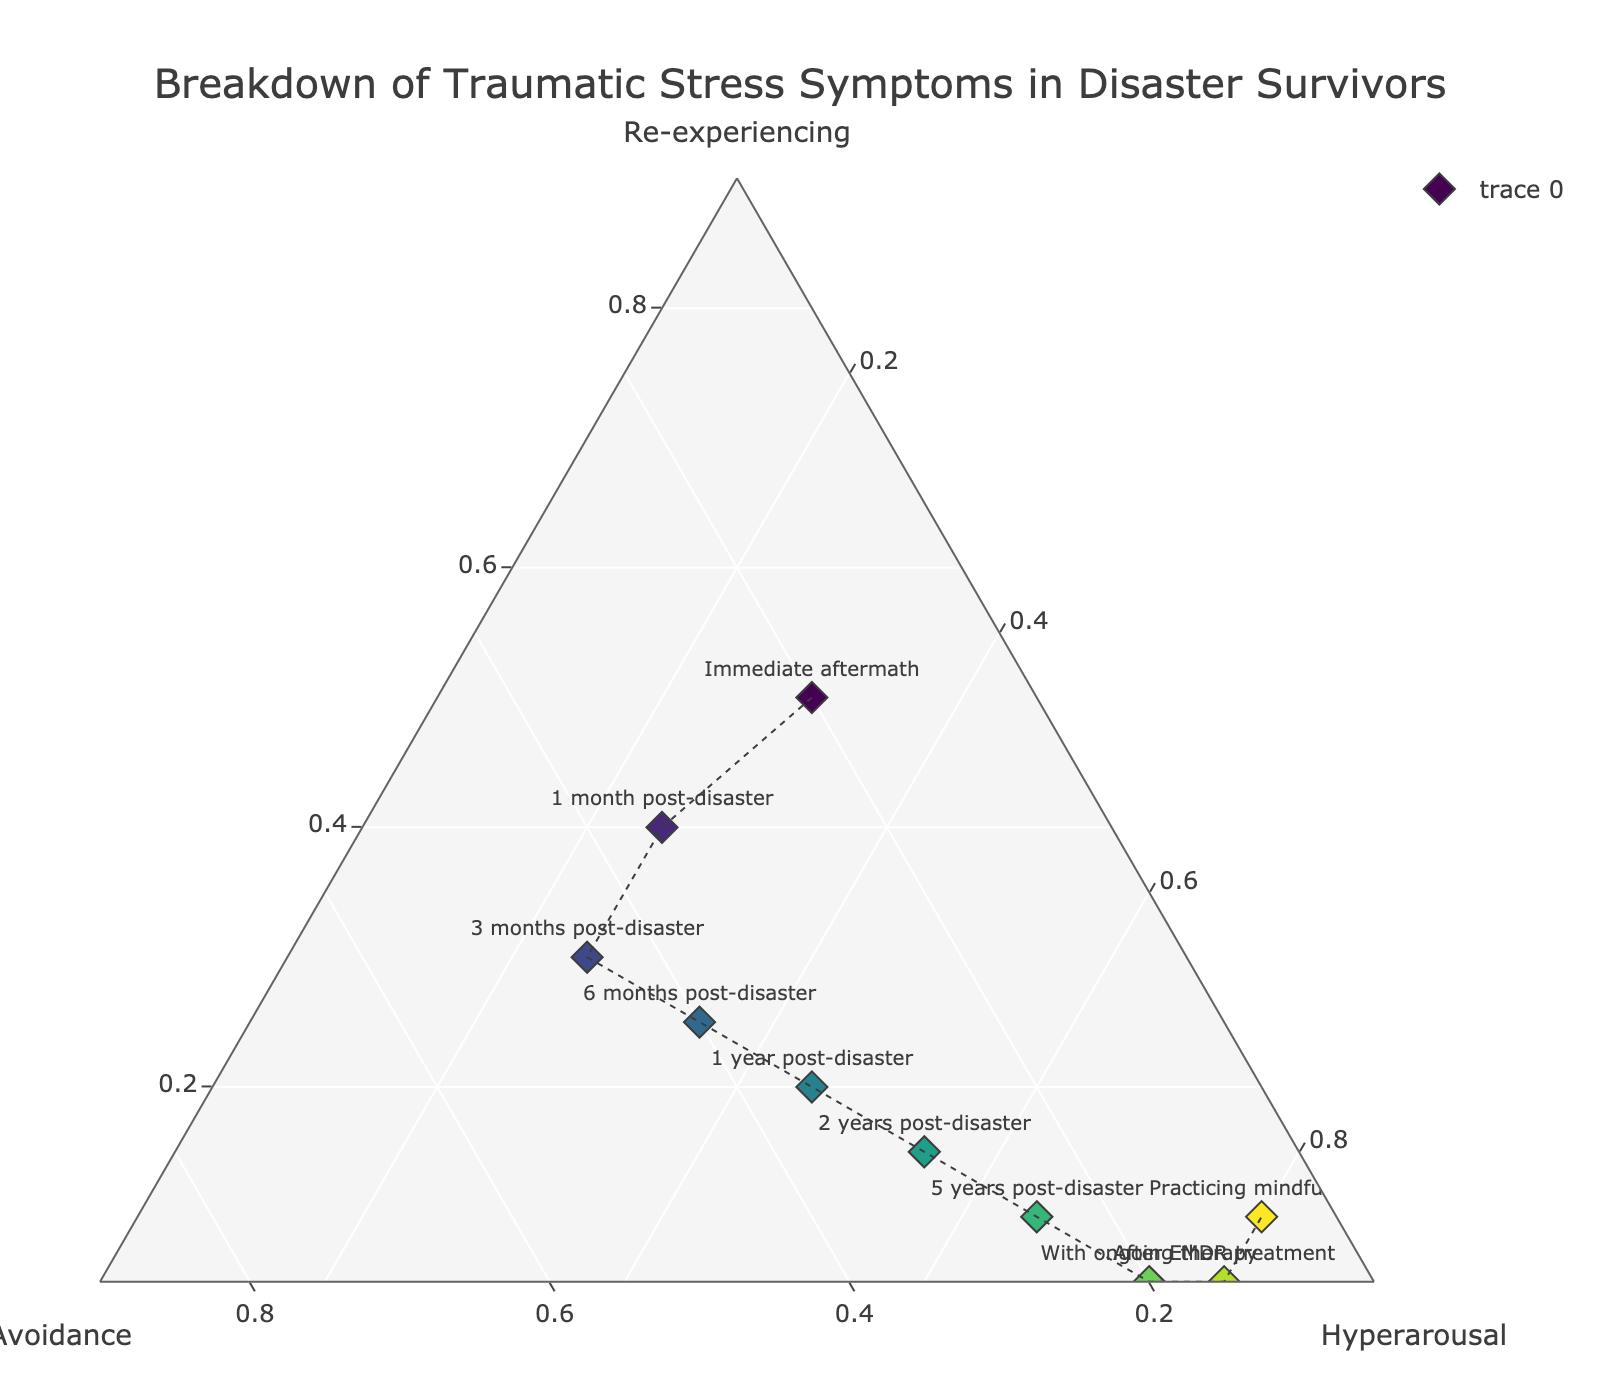What's the title of the figure? The title is usually located at the top center of the plot. In this case, it states what the figure is about.
Answer: Breakdown of Traumatic Stress Symptoms in Disaster Survivors What are the three main categories being measured in the ternary plot? By looking at the three corners of the ternary plot, we can identify the categories as each corner represents a different symptom.
Answer: Re-experiencing, Avoidance, and Hyperarousal Which stage has the highest proportion of Hyperarousal? The data point farthest towards the Hyperarousal corner would indicate the highest proportion. In this case, it is the point labeled "Practicing mindfulness".
Answer: Practicing mindfulness How does the proportion of Re-experiencing change from the Immediate aftermath to 1 year post-disaster? Compare the positions of the data points "Immediate aftermath" and "1 year post-disaster" along the Re-experiencing axis. The proportion decreases over time.
Answer: It decreases from 50% to 20% Which stages show a higher proportion of Avoidance compared to Hyperarousal? Identify the points where the Avoidance axis length is greater than the Hyperarousal axis length. This happens at "1 month post-disaster", "3 months post-disaster", and "6 months post-disaster".
Answer: 1 month post-disaster, 3 months post-disaster, 6 months post-disaster At what stage does Re-experiencing drop below 10%? Identify the stage which has Re-experiencing less than 10% by finding the corresponding data points close to the Avoidance-Hyperarousal axis boundary.
Answer: 5 years post-disaster Which stage shows an equal proportion of Avoidance and Hyperarousal? Find the point where the values along the Avoidance and Hyperarousal axes are equal. This occurs at "Practicing mindfulness".
Answer: Practicing mindfulness What trend can be observed in the proportions of Hyperarousal over the recovery stages? Look at the sequence of points from the Immediate aftermath to Practicing mindfulness and note if the Hyperarousal values increase or decrease.
Answer: The proportion of Hyperarousal generally increases over time Compare the proportions of Re-experiencing between "After EMDR treatment" and "With ongoing therapy". By comparing their positions, we see both stages have the same proportion of Re-experiencing which is very low.
Answer: They have the same proportion (5%) Which stage has the lowest proportion of Avoidance? Find the data point closest to the opposite side of the Avoidance axis.
Answer: Practicing mindfulness 